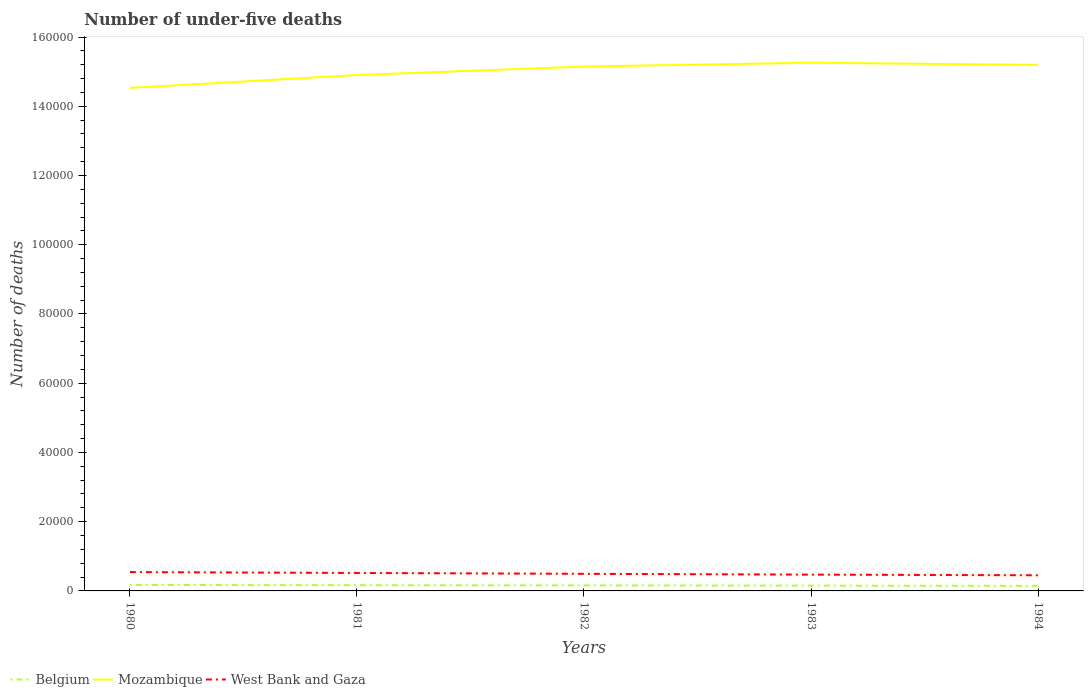Does the line corresponding to Mozambique intersect with the line corresponding to Belgium?
Offer a terse response. No. Across all years, what is the maximum number of under-five deaths in Mozambique?
Your answer should be very brief. 1.45e+05. What is the total number of under-five deaths in Belgium in the graph?
Your response must be concise. 182. What is the difference between the highest and the second highest number of under-five deaths in Mozambique?
Provide a succinct answer. 7289. What is the difference between two consecutive major ticks on the Y-axis?
Give a very brief answer. 2.00e+04. Does the graph contain any zero values?
Provide a succinct answer. No. How many legend labels are there?
Provide a succinct answer. 3. How are the legend labels stacked?
Provide a succinct answer. Horizontal. What is the title of the graph?
Your response must be concise. Number of under-five deaths. What is the label or title of the Y-axis?
Give a very brief answer. Number of deaths. What is the Number of deaths in Belgium in 1980?
Give a very brief answer. 1731. What is the Number of deaths in Mozambique in 1980?
Offer a terse response. 1.45e+05. What is the Number of deaths in West Bank and Gaza in 1980?
Your answer should be very brief. 5438. What is the Number of deaths in Belgium in 1981?
Ensure brevity in your answer.  1651. What is the Number of deaths in Mozambique in 1981?
Your response must be concise. 1.49e+05. What is the Number of deaths of West Bank and Gaza in 1981?
Keep it short and to the point. 5189. What is the Number of deaths in Belgium in 1982?
Keep it short and to the point. 1583. What is the Number of deaths of Mozambique in 1982?
Give a very brief answer. 1.51e+05. What is the Number of deaths in West Bank and Gaza in 1982?
Make the answer very short. 4938. What is the Number of deaths of Belgium in 1983?
Your response must be concise. 1520. What is the Number of deaths in Mozambique in 1983?
Keep it short and to the point. 1.53e+05. What is the Number of deaths in West Bank and Gaza in 1983?
Offer a terse response. 4707. What is the Number of deaths of Belgium in 1984?
Your answer should be compact. 1469. What is the Number of deaths of Mozambique in 1984?
Ensure brevity in your answer.  1.52e+05. What is the Number of deaths of West Bank and Gaza in 1984?
Ensure brevity in your answer.  4516. Across all years, what is the maximum Number of deaths in Belgium?
Your response must be concise. 1731. Across all years, what is the maximum Number of deaths in Mozambique?
Offer a very short reply. 1.53e+05. Across all years, what is the maximum Number of deaths in West Bank and Gaza?
Keep it short and to the point. 5438. Across all years, what is the minimum Number of deaths of Belgium?
Offer a very short reply. 1469. Across all years, what is the minimum Number of deaths of Mozambique?
Your response must be concise. 1.45e+05. Across all years, what is the minimum Number of deaths of West Bank and Gaza?
Ensure brevity in your answer.  4516. What is the total Number of deaths of Belgium in the graph?
Ensure brevity in your answer.  7954. What is the total Number of deaths of Mozambique in the graph?
Ensure brevity in your answer.  7.50e+05. What is the total Number of deaths of West Bank and Gaza in the graph?
Your response must be concise. 2.48e+04. What is the difference between the Number of deaths of Mozambique in 1980 and that in 1981?
Keep it short and to the point. -3730. What is the difference between the Number of deaths in West Bank and Gaza in 1980 and that in 1981?
Your answer should be compact. 249. What is the difference between the Number of deaths in Belgium in 1980 and that in 1982?
Keep it short and to the point. 148. What is the difference between the Number of deaths of Mozambique in 1980 and that in 1982?
Offer a terse response. -6186. What is the difference between the Number of deaths in Belgium in 1980 and that in 1983?
Provide a short and direct response. 211. What is the difference between the Number of deaths of Mozambique in 1980 and that in 1983?
Offer a terse response. -7289. What is the difference between the Number of deaths of West Bank and Gaza in 1980 and that in 1983?
Ensure brevity in your answer.  731. What is the difference between the Number of deaths of Belgium in 1980 and that in 1984?
Your answer should be very brief. 262. What is the difference between the Number of deaths in Mozambique in 1980 and that in 1984?
Offer a very short reply. -6676. What is the difference between the Number of deaths of West Bank and Gaza in 1980 and that in 1984?
Provide a short and direct response. 922. What is the difference between the Number of deaths in Belgium in 1981 and that in 1982?
Make the answer very short. 68. What is the difference between the Number of deaths of Mozambique in 1981 and that in 1982?
Make the answer very short. -2456. What is the difference between the Number of deaths of West Bank and Gaza in 1981 and that in 1982?
Give a very brief answer. 251. What is the difference between the Number of deaths in Belgium in 1981 and that in 1983?
Your response must be concise. 131. What is the difference between the Number of deaths in Mozambique in 1981 and that in 1983?
Keep it short and to the point. -3559. What is the difference between the Number of deaths of West Bank and Gaza in 1981 and that in 1983?
Offer a terse response. 482. What is the difference between the Number of deaths in Belgium in 1981 and that in 1984?
Ensure brevity in your answer.  182. What is the difference between the Number of deaths in Mozambique in 1981 and that in 1984?
Provide a succinct answer. -2946. What is the difference between the Number of deaths of West Bank and Gaza in 1981 and that in 1984?
Your answer should be compact. 673. What is the difference between the Number of deaths of Belgium in 1982 and that in 1983?
Give a very brief answer. 63. What is the difference between the Number of deaths of Mozambique in 1982 and that in 1983?
Keep it short and to the point. -1103. What is the difference between the Number of deaths in West Bank and Gaza in 1982 and that in 1983?
Make the answer very short. 231. What is the difference between the Number of deaths in Belgium in 1982 and that in 1984?
Give a very brief answer. 114. What is the difference between the Number of deaths in Mozambique in 1982 and that in 1984?
Give a very brief answer. -490. What is the difference between the Number of deaths of West Bank and Gaza in 1982 and that in 1984?
Your response must be concise. 422. What is the difference between the Number of deaths of Belgium in 1983 and that in 1984?
Offer a very short reply. 51. What is the difference between the Number of deaths in Mozambique in 1983 and that in 1984?
Provide a succinct answer. 613. What is the difference between the Number of deaths in West Bank and Gaza in 1983 and that in 1984?
Your response must be concise. 191. What is the difference between the Number of deaths of Belgium in 1980 and the Number of deaths of Mozambique in 1981?
Provide a succinct answer. -1.47e+05. What is the difference between the Number of deaths in Belgium in 1980 and the Number of deaths in West Bank and Gaza in 1981?
Give a very brief answer. -3458. What is the difference between the Number of deaths of Mozambique in 1980 and the Number of deaths of West Bank and Gaza in 1981?
Ensure brevity in your answer.  1.40e+05. What is the difference between the Number of deaths in Belgium in 1980 and the Number of deaths in Mozambique in 1982?
Your answer should be compact. -1.50e+05. What is the difference between the Number of deaths of Belgium in 1980 and the Number of deaths of West Bank and Gaza in 1982?
Offer a terse response. -3207. What is the difference between the Number of deaths in Mozambique in 1980 and the Number of deaths in West Bank and Gaza in 1982?
Your answer should be compact. 1.40e+05. What is the difference between the Number of deaths in Belgium in 1980 and the Number of deaths in Mozambique in 1983?
Your response must be concise. -1.51e+05. What is the difference between the Number of deaths in Belgium in 1980 and the Number of deaths in West Bank and Gaza in 1983?
Your answer should be very brief. -2976. What is the difference between the Number of deaths in Mozambique in 1980 and the Number of deaths in West Bank and Gaza in 1983?
Your answer should be very brief. 1.41e+05. What is the difference between the Number of deaths of Belgium in 1980 and the Number of deaths of Mozambique in 1984?
Provide a succinct answer. -1.50e+05. What is the difference between the Number of deaths in Belgium in 1980 and the Number of deaths in West Bank and Gaza in 1984?
Give a very brief answer. -2785. What is the difference between the Number of deaths of Mozambique in 1980 and the Number of deaths of West Bank and Gaza in 1984?
Give a very brief answer. 1.41e+05. What is the difference between the Number of deaths of Belgium in 1981 and the Number of deaths of Mozambique in 1982?
Your answer should be compact. -1.50e+05. What is the difference between the Number of deaths in Belgium in 1981 and the Number of deaths in West Bank and Gaza in 1982?
Offer a terse response. -3287. What is the difference between the Number of deaths of Mozambique in 1981 and the Number of deaths of West Bank and Gaza in 1982?
Offer a very short reply. 1.44e+05. What is the difference between the Number of deaths of Belgium in 1981 and the Number of deaths of Mozambique in 1983?
Offer a very short reply. -1.51e+05. What is the difference between the Number of deaths in Belgium in 1981 and the Number of deaths in West Bank and Gaza in 1983?
Keep it short and to the point. -3056. What is the difference between the Number of deaths of Mozambique in 1981 and the Number of deaths of West Bank and Gaza in 1983?
Provide a succinct answer. 1.44e+05. What is the difference between the Number of deaths of Belgium in 1981 and the Number of deaths of Mozambique in 1984?
Your answer should be compact. -1.50e+05. What is the difference between the Number of deaths of Belgium in 1981 and the Number of deaths of West Bank and Gaza in 1984?
Keep it short and to the point. -2865. What is the difference between the Number of deaths in Mozambique in 1981 and the Number of deaths in West Bank and Gaza in 1984?
Your answer should be very brief. 1.44e+05. What is the difference between the Number of deaths in Belgium in 1982 and the Number of deaths in Mozambique in 1983?
Provide a short and direct response. -1.51e+05. What is the difference between the Number of deaths in Belgium in 1982 and the Number of deaths in West Bank and Gaza in 1983?
Offer a very short reply. -3124. What is the difference between the Number of deaths of Mozambique in 1982 and the Number of deaths of West Bank and Gaza in 1983?
Your answer should be very brief. 1.47e+05. What is the difference between the Number of deaths of Belgium in 1982 and the Number of deaths of Mozambique in 1984?
Make the answer very short. -1.50e+05. What is the difference between the Number of deaths of Belgium in 1982 and the Number of deaths of West Bank and Gaza in 1984?
Offer a terse response. -2933. What is the difference between the Number of deaths in Mozambique in 1982 and the Number of deaths in West Bank and Gaza in 1984?
Keep it short and to the point. 1.47e+05. What is the difference between the Number of deaths in Belgium in 1983 and the Number of deaths in Mozambique in 1984?
Provide a succinct answer. -1.50e+05. What is the difference between the Number of deaths in Belgium in 1983 and the Number of deaths in West Bank and Gaza in 1984?
Your answer should be very brief. -2996. What is the difference between the Number of deaths of Mozambique in 1983 and the Number of deaths of West Bank and Gaza in 1984?
Make the answer very short. 1.48e+05. What is the average Number of deaths of Belgium per year?
Ensure brevity in your answer.  1590.8. What is the average Number of deaths of Mozambique per year?
Your answer should be very brief. 1.50e+05. What is the average Number of deaths of West Bank and Gaza per year?
Your response must be concise. 4957.6. In the year 1980, what is the difference between the Number of deaths of Belgium and Number of deaths of Mozambique?
Provide a succinct answer. -1.44e+05. In the year 1980, what is the difference between the Number of deaths in Belgium and Number of deaths in West Bank and Gaza?
Ensure brevity in your answer.  -3707. In the year 1980, what is the difference between the Number of deaths of Mozambique and Number of deaths of West Bank and Gaza?
Your answer should be very brief. 1.40e+05. In the year 1981, what is the difference between the Number of deaths in Belgium and Number of deaths in Mozambique?
Provide a succinct answer. -1.47e+05. In the year 1981, what is the difference between the Number of deaths in Belgium and Number of deaths in West Bank and Gaza?
Your response must be concise. -3538. In the year 1981, what is the difference between the Number of deaths in Mozambique and Number of deaths in West Bank and Gaza?
Provide a succinct answer. 1.44e+05. In the year 1982, what is the difference between the Number of deaths of Belgium and Number of deaths of Mozambique?
Your answer should be very brief. -1.50e+05. In the year 1982, what is the difference between the Number of deaths of Belgium and Number of deaths of West Bank and Gaza?
Offer a terse response. -3355. In the year 1982, what is the difference between the Number of deaths in Mozambique and Number of deaths in West Bank and Gaza?
Keep it short and to the point. 1.47e+05. In the year 1983, what is the difference between the Number of deaths of Belgium and Number of deaths of Mozambique?
Provide a succinct answer. -1.51e+05. In the year 1983, what is the difference between the Number of deaths in Belgium and Number of deaths in West Bank and Gaza?
Your answer should be very brief. -3187. In the year 1983, what is the difference between the Number of deaths of Mozambique and Number of deaths of West Bank and Gaza?
Make the answer very short. 1.48e+05. In the year 1984, what is the difference between the Number of deaths in Belgium and Number of deaths in Mozambique?
Provide a succinct answer. -1.50e+05. In the year 1984, what is the difference between the Number of deaths in Belgium and Number of deaths in West Bank and Gaza?
Your answer should be compact. -3047. In the year 1984, what is the difference between the Number of deaths in Mozambique and Number of deaths in West Bank and Gaza?
Your answer should be very brief. 1.47e+05. What is the ratio of the Number of deaths of Belgium in 1980 to that in 1981?
Make the answer very short. 1.05. What is the ratio of the Number of deaths of West Bank and Gaza in 1980 to that in 1981?
Keep it short and to the point. 1.05. What is the ratio of the Number of deaths in Belgium in 1980 to that in 1982?
Your answer should be very brief. 1.09. What is the ratio of the Number of deaths of Mozambique in 1980 to that in 1982?
Offer a terse response. 0.96. What is the ratio of the Number of deaths of West Bank and Gaza in 1980 to that in 1982?
Ensure brevity in your answer.  1.1. What is the ratio of the Number of deaths in Belgium in 1980 to that in 1983?
Give a very brief answer. 1.14. What is the ratio of the Number of deaths in Mozambique in 1980 to that in 1983?
Your response must be concise. 0.95. What is the ratio of the Number of deaths in West Bank and Gaza in 1980 to that in 1983?
Offer a very short reply. 1.16. What is the ratio of the Number of deaths in Belgium in 1980 to that in 1984?
Ensure brevity in your answer.  1.18. What is the ratio of the Number of deaths in Mozambique in 1980 to that in 1984?
Offer a terse response. 0.96. What is the ratio of the Number of deaths in West Bank and Gaza in 1980 to that in 1984?
Your response must be concise. 1.2. What is the ratio of the Number of deaths in Belgium in 1981 to that in 1982?
Provide a short and direct response. 1.04. What is the ratio of the Number of deaths in Mozambique in 1981 to that in 1982?
Your response must be concise. 0.98. What is the ratio of the Number of deaths in West Bank and Gaza in 1981 to that in 1982?
Make the answer very short. 1.05. What is the ratio of the Number of deaths of Belgium in 1981 to that in 1983?
Provide a short and direct response. 1.09. What is the ratio of the Number of deaths in Mozambique in 1981 to that in 1983?
Ensure brevity in your answer.  0.98. What is the ratio of the Number of deaths of West Bank and Gaza in 1981 to that in 1983?
Your response must be concise. 1.1. What is the ratio of the Number of deaths in Belgium in 1981 to that in 1984?
Provide a succinct answer. 1.12. What is the ratio of the Number of deaths of Mozambique in 1981 to that in 1984?
Offer a terse response. 0.98. What is the ratio of the Number of deaths of West Bank and Gaza in 1981 to that in 1984?
Offer a terse response. 1.15. What is the ratio of the Number of deaths in Belgium in 1982 to that in 1983?
Keep it short and to the point. 1.04. What is the ratio of the Number of deaths in Mozambique in 1982 to that in 1983?
Ensure brevity in your answer.  0.99. What is the ratio of the Number of deaths in West Bank and Gaza in 1982 to that in 1983?
Offer a very short reply. 1.05. What is the ratio of the Number of deaths of Belgium in 1982 to that in 1984?
Your response must be concise. 1.08. What is the ratio of the Number of deaths in West Bank and Gaza in 1982 to that in 1984?
Give a very brief answer. 1.09. What is the ratio of the Number of deaths in Belgium in 1983 to that in 1984?
Give a very brief answer. 1.03. What is the ratio of the Number of deaths of West Bank and Gaza in 1983 to that in 1984?
Provide a succinct answer. 1.04. What is the difference between the highest and the second highest Number of deaths in Belgium?
Offer a very short reply. 80. What is the difference between the highest and the second highest Number of deaths in Mozambique?
Offer a very short reply. 613. What is the difference between the highest and the second highest Number of deaths of West Bank and Gaza?
Offer a very short reply. 249. What is the difference between the highest and the lowest Number of deaths in Belgium?
Provide a short and direct response. 262. What is the difference between the highest and the lowest Number of deaths of Mozambique?
Your answer should be compact. 7289. What is the difference between the highest and the lowest Number of deaths in West Bank and Gaza?
Ensure brevity in your answer.  922. 